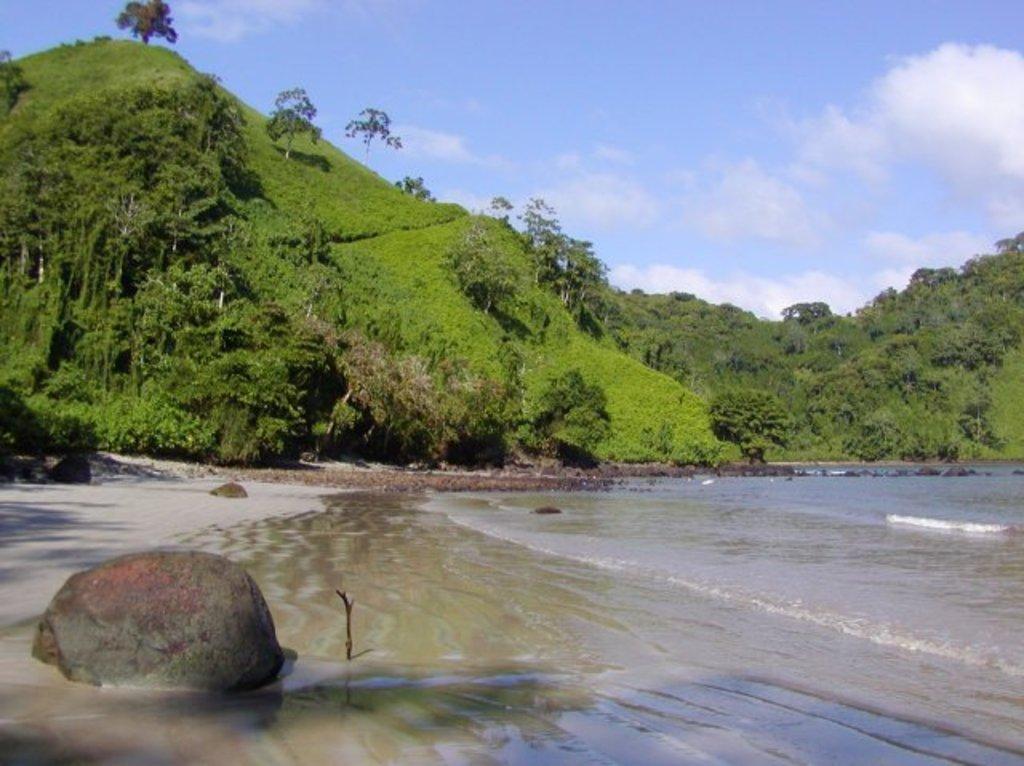Please provide a concise description of this image. We can see water and stone. Background we can see trees,grass,hills and sky with clouds. 